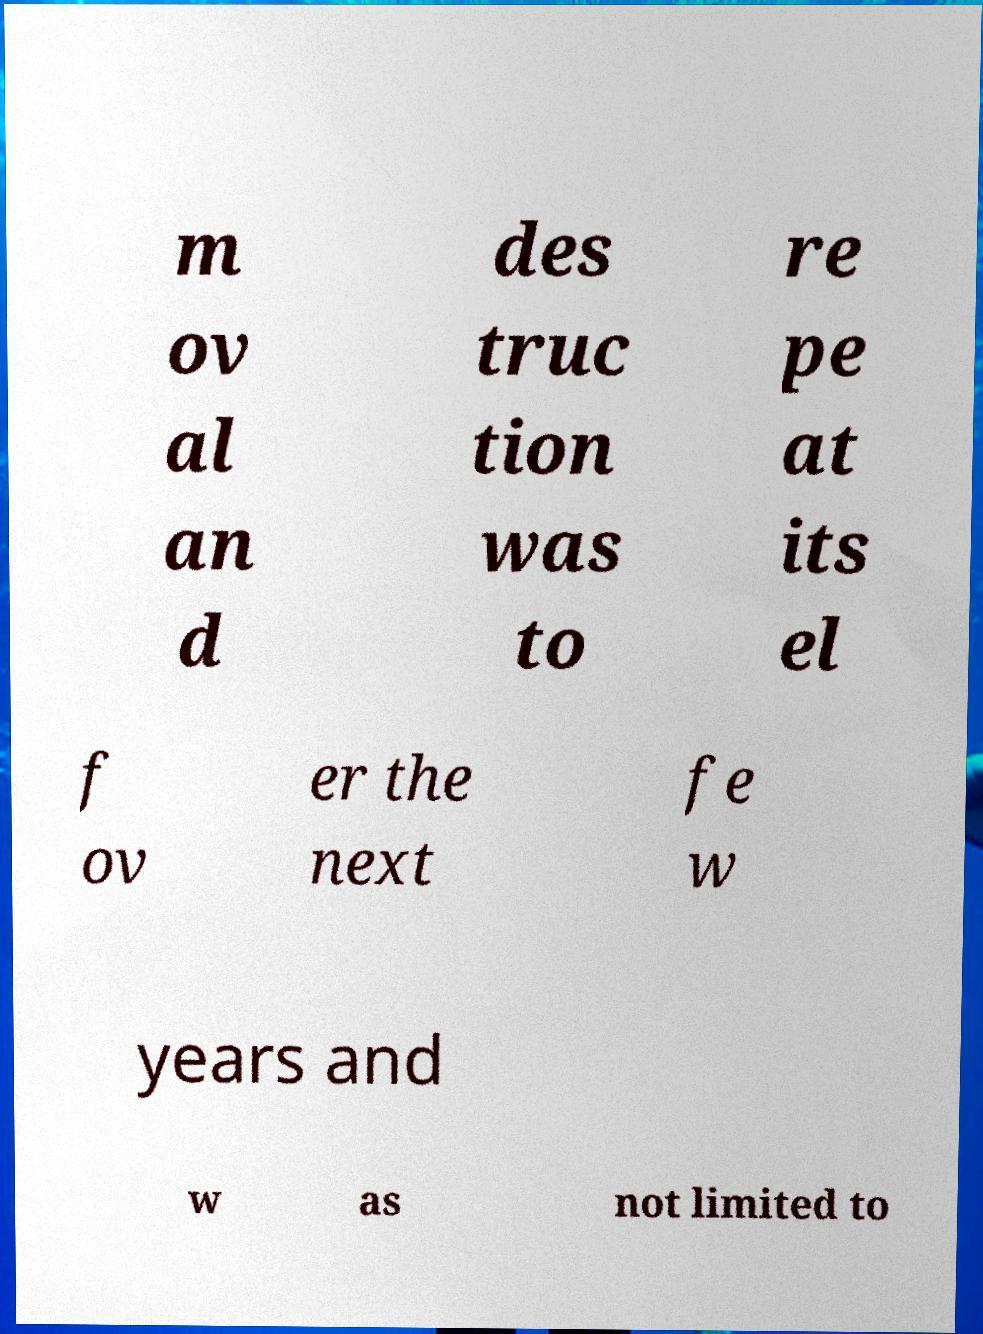I need the written content from this picture converted into text. Can you do that? m ov al an d des truc tion was to re pe at its el f ov er the next fe w years and w as not limited to 